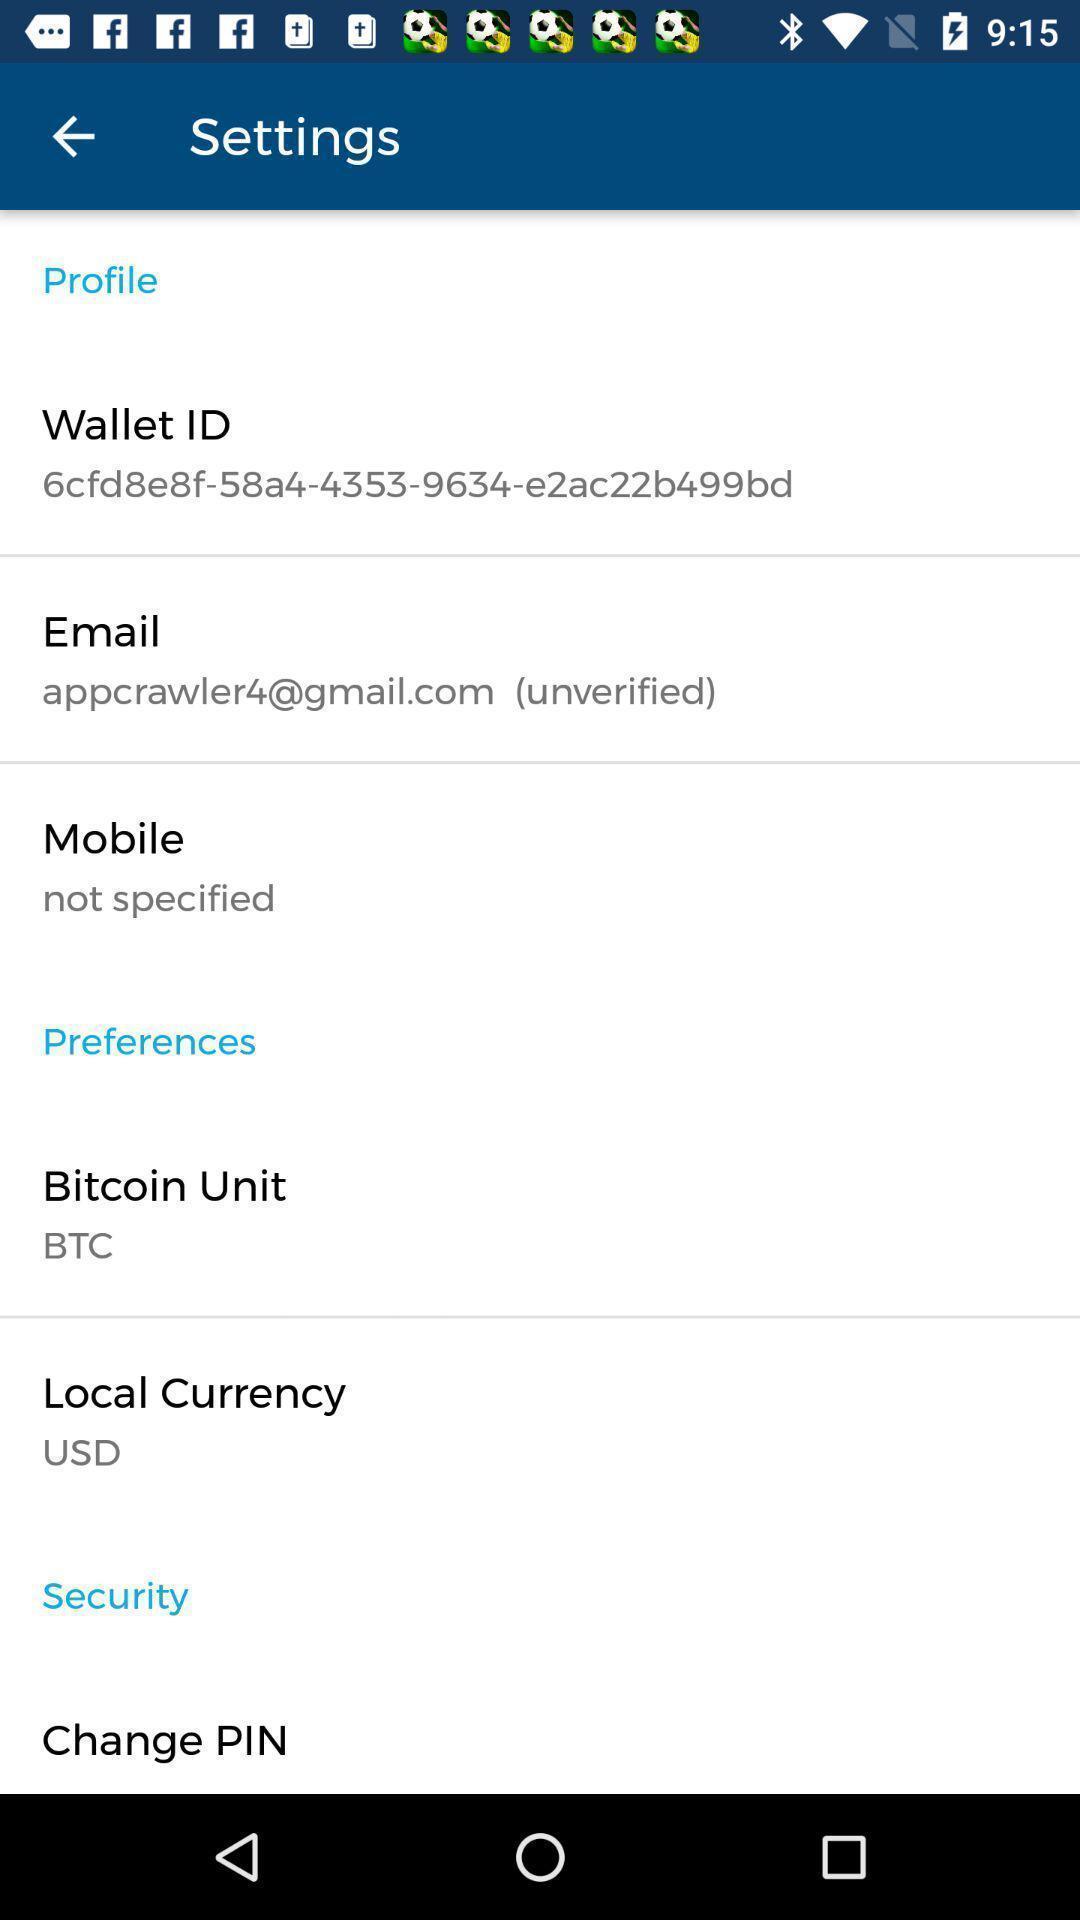Tell me what you see in this picture. Settings page of profile. 